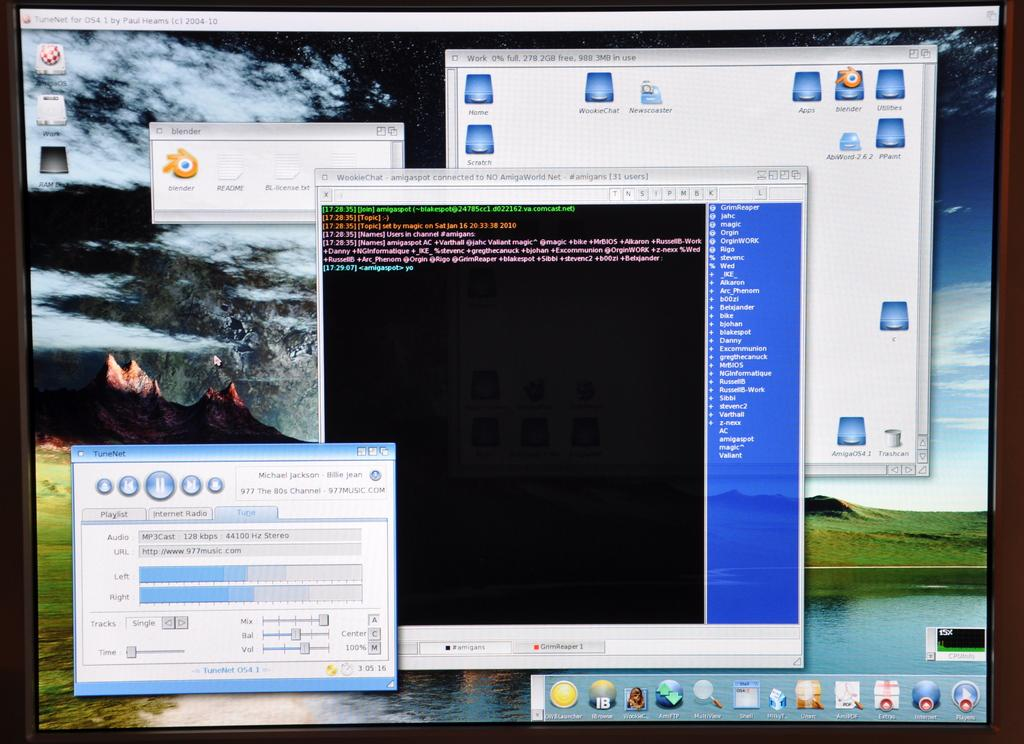<image>
Provide a brief description of the given image. A computer screen shows that the TuneNet program is open. 